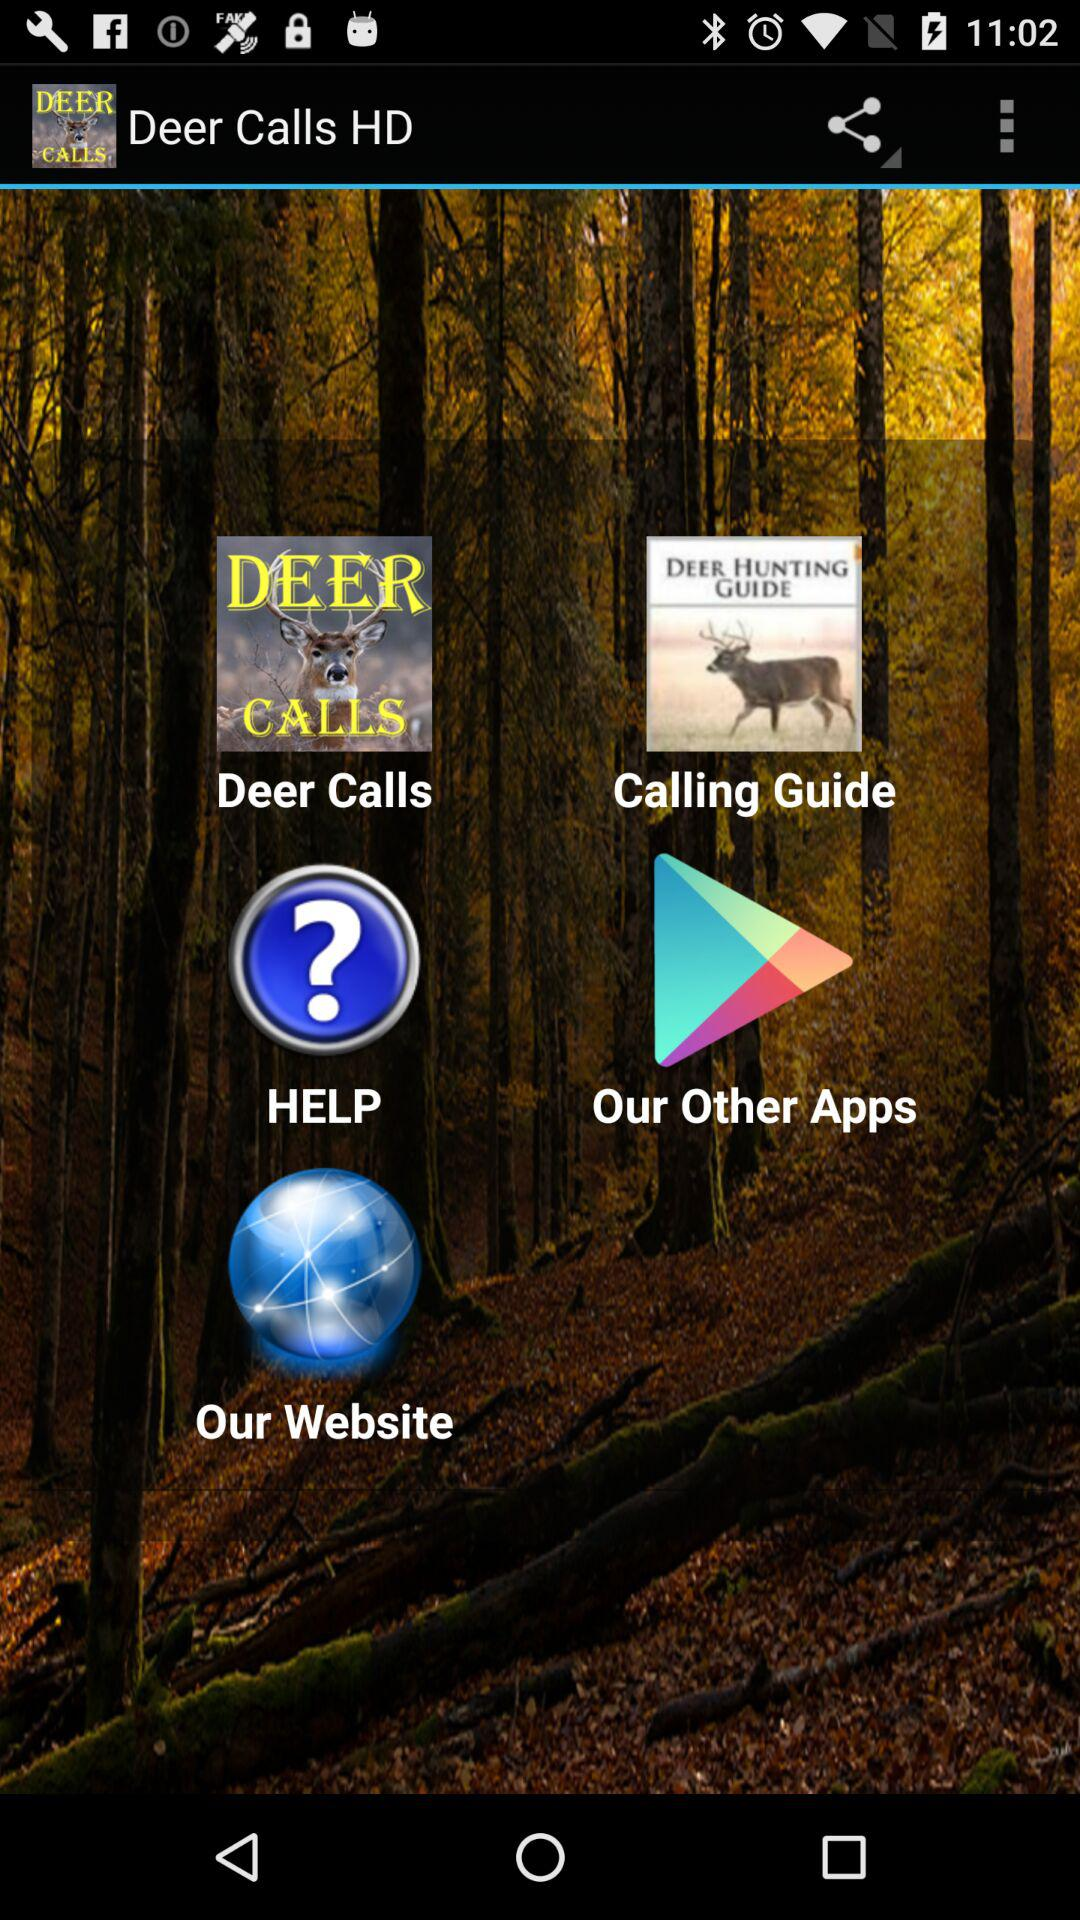What is the name of the application? The name of the application is "Deer Calls HD". 